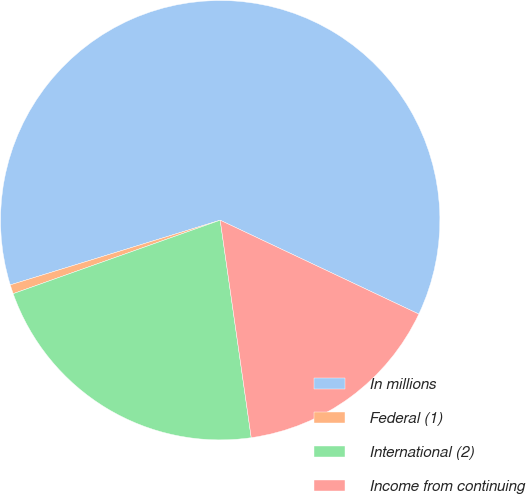Convert chart. <chart><loc_0><loc_0><loc_500><loc_500><pie_chart><fcel>In millions<fcel>Federal (1)<fcel>International (2)<fcel>Income from continuing<nl><fcel>61.79%<fcel>0.67%<fcel>21.83%<fcel>15.72%<nl></chart> 